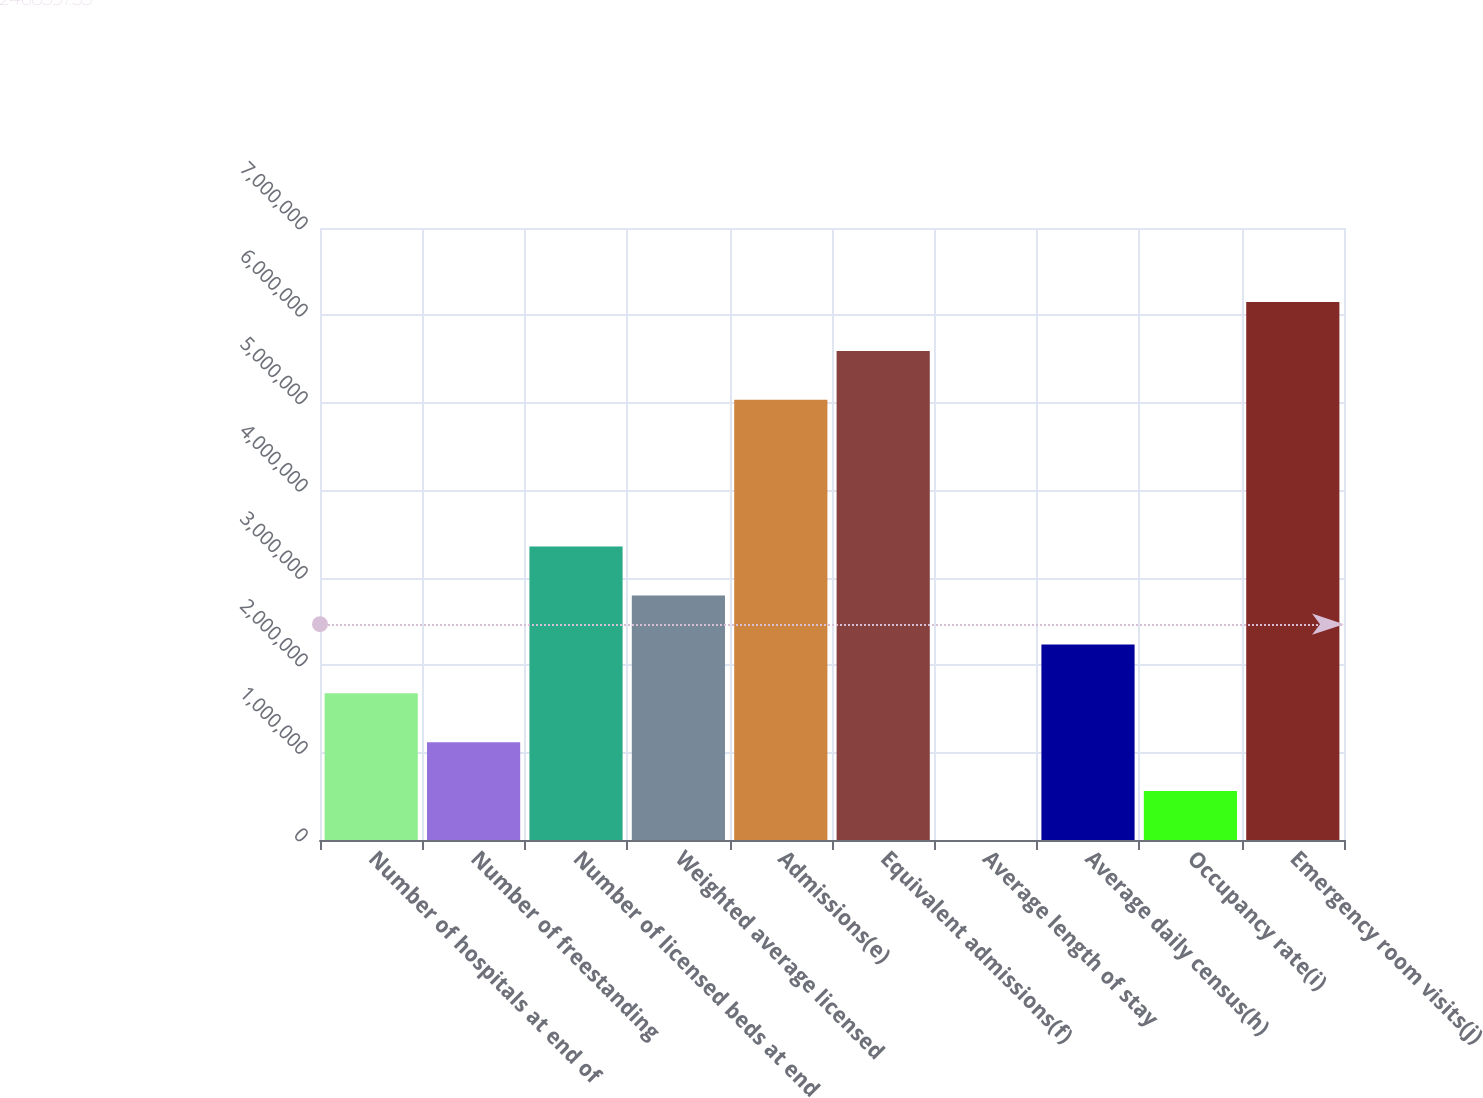Convert chart. <chart><loc_0><loc_0><loc_500><loc_500><bar_chart><fcel>Number of hospitals at end of<fcel>Number of freestanding<fcel>Number of licensed beds at end<fcel>Weighted average licensed<fcel>Admissions(e)<fcel>Equivalent admissions(f)<fcel>Average length of stay<fcel>Average daily census(h)<fcel>Occupancy rate(i)<fcel>Emergency room visits(j)<nl><fcel>1.67805e+06<fcel>1.1187e+06<fcel>3.3561e+06<fcel>2.79675e+06<fcel>5.03415e+06<fcel>5.5935e+06<fcel>4.8<fcel>2.2374e+06<fcel>559354<fcel>6.15285e+06<nl></chart> 